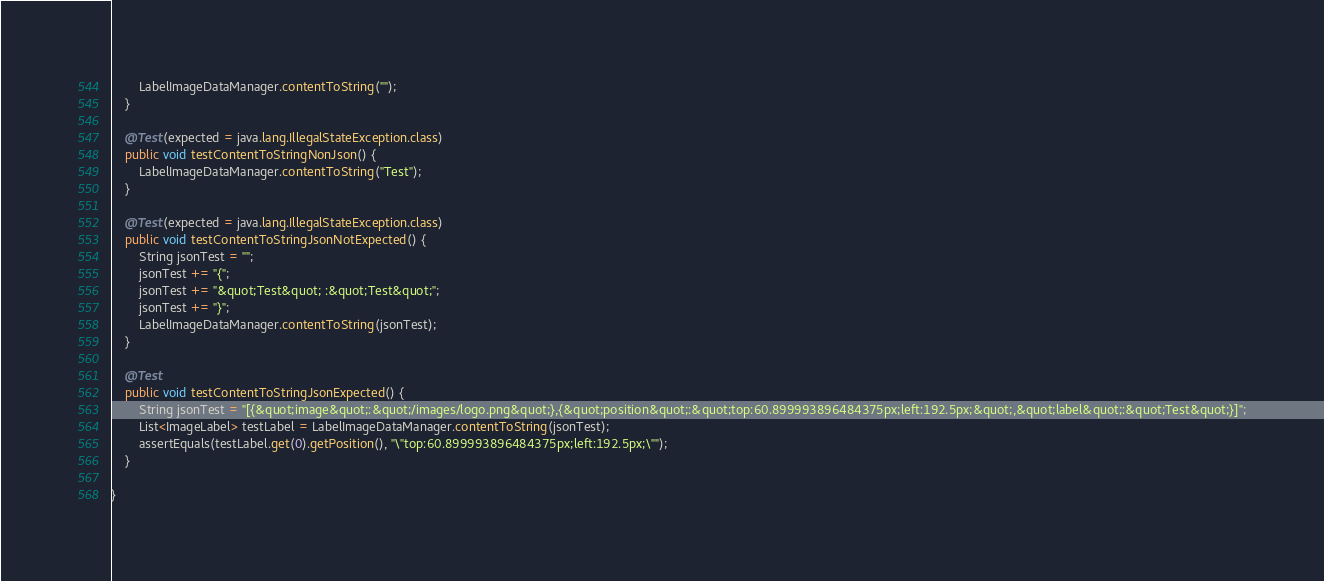<code> <loc_0><loc_0><loc_500><loc_500><_Java_>		LabelImageDataManager.contentToString("");
	}

	@Test(expected = java.lang.IllegalStateException.class)
	public void testContentToStringNonJson() {
		LabelImageDataManager.contentToString("Test");
	}

	@Test(expected = java.lang.IllegalStateException.class)
	public void testContentToStringJsonNotExpected() {
		String jsonTest = "";
		jsonTest += "{";
		jsonTest += "&quot;Test&quot; :&quot;Test&quot;";
		jsonTest += "}";
		LabelImageDataManager.contentToString(jsonTest);
	}

	@Test
	public void testContentToStringJsonExpected() {
		String jsonTest = "[{&quot;image&quot;:&quot;/images/logo.png&quot;},{&quot;position&quot;:&quot;top:60.899993896484375px;left:192.5px;&quot;,&quot;label&quot;:&quot;Test&quot;}]";
		List<ImageLabel> testLabel = LabelImageDataManager.contentToString(jsonTest);
		assertEquals(testLabel.get(0).getPosition(), "\"top:60.899993896484375px;left:192.5px;\"");
	}

}
</code> 